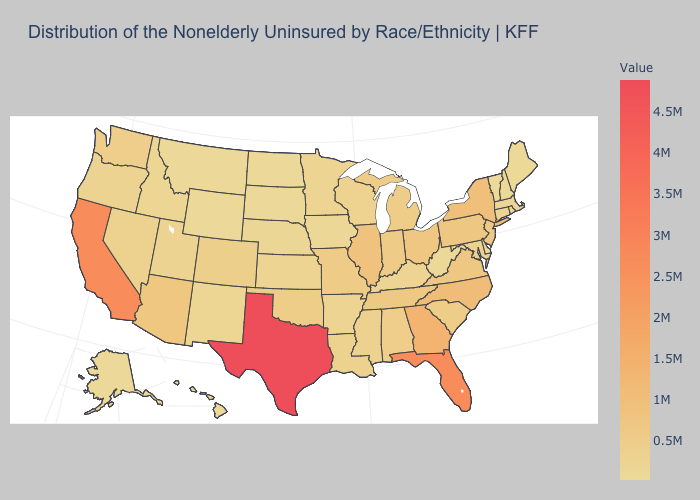Which states hav the highest value in the MidWest?
Answer briefly. Illinois. Which states have the lowest value in the USA?
Write a very short answer. Vermont. Among the states that border Georgia , which have the highest value?
Be succinct. Florida. Among the states that border New Mexico , does Utah have the lowest value?
Short answer required. Yes. Does Hawaii have the highest value in the West?
Short answer required. No. Among the states that border New Jersey , which have the lowest value?
Answer briefly. Delaware. 